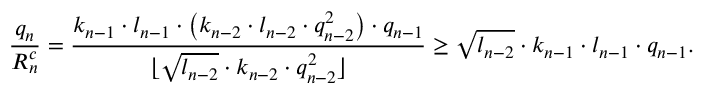<formula> <loc_0><loc_0><loc_500><loc_500>\frac { q _ { n } } { R _ { n } ^ { c } } = \frac { k _ { n - 1 } \cdot l _ { n - 1 } \cdot \left ( k _ { n - 2 } \cdot l _ { n - 2 } \cdot q _ { n - 2 } ^ { 2 } \right ) \cdot q _ { n - 1 } } { \lfloor \sqrt { l _ { n - 2 } } \cdot k _ { n - 2 } \cdot q _ { n - 2 } ^ { 2 } \rfloor } \geq \sqrt { l _ { n - 2 } } \cdot k _ { n - 1 } \cdot l _ { n - 1 } \cdot q _ { n - 1 } .</formula> 